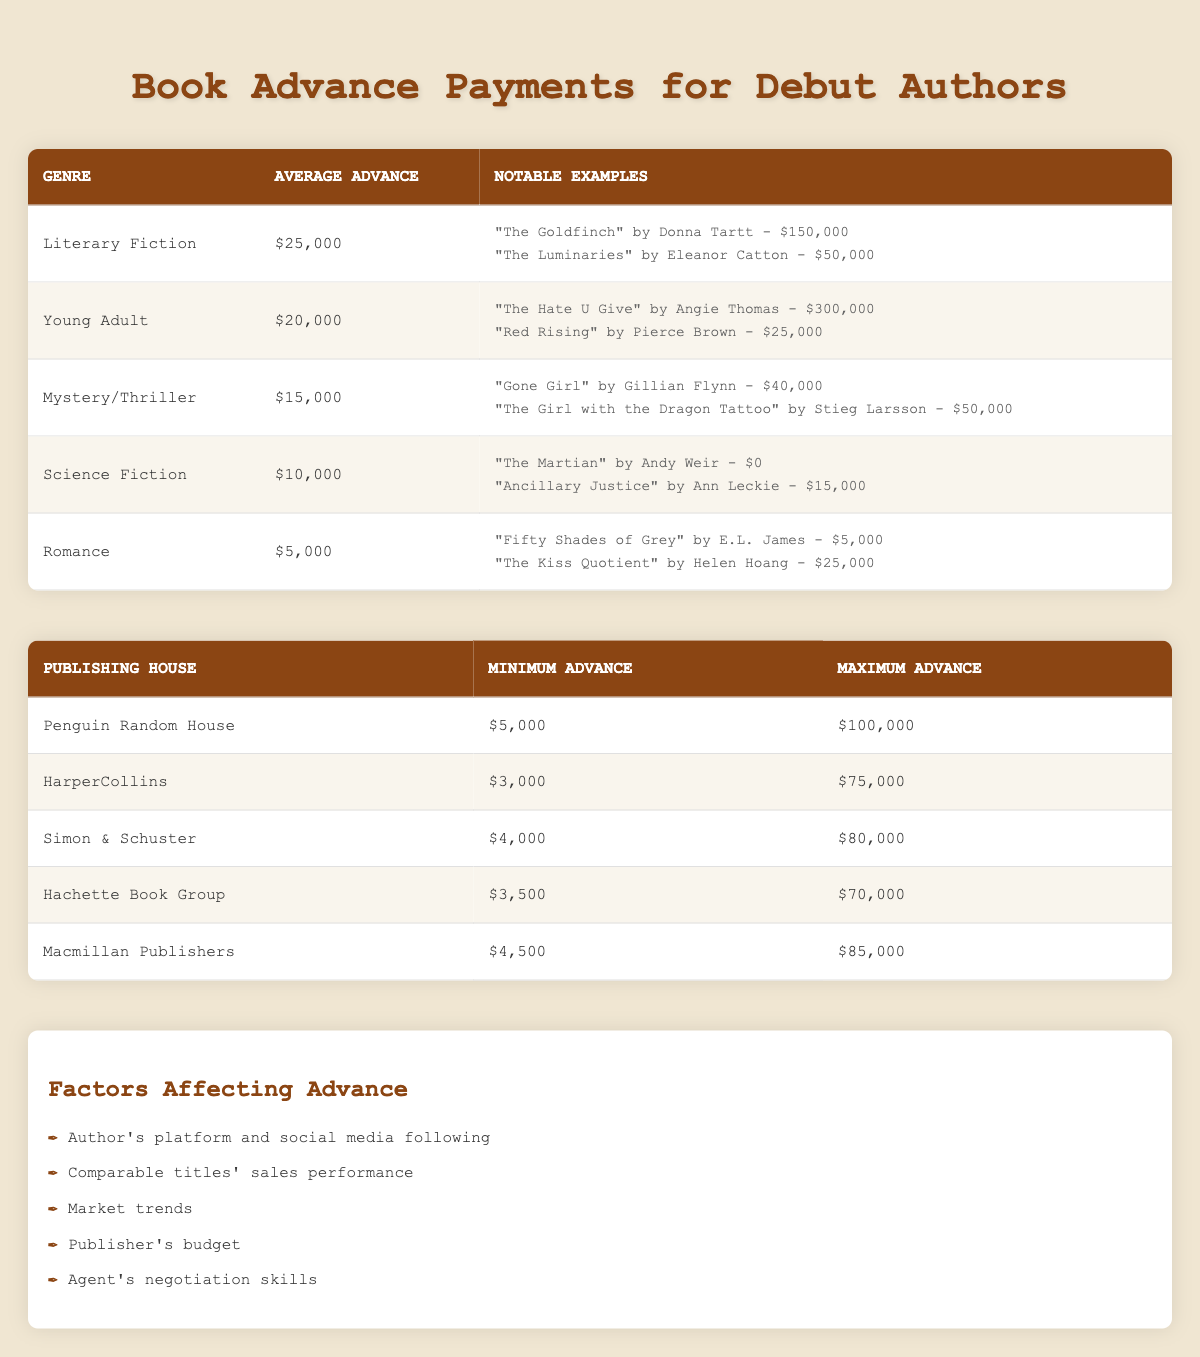What is the average advance for debut authors in the Romance genre? The table shows the average advance for the Romance genre as $5,000 directly under the "Average Advance" column.
Answer: $5,000 Which notable book received the highest advance and what was the amount? Looking at the notable examples in each genre, "The Hate U Give" by Angie Thomas received the highest advance of $300,000.
Answer: $300,000 How much more is the average advance for Young Adult authors compared to Mystery/Thriller authors? The average advance for Young Adult is $20,000 and for Mystery/Thriller it is $15,000. The difference is $20,000 - $15,000 = $5,000.
Answer: $5,000 Do all genres listed have an average advance greater than $5,000? Checking the average advances, Romance has an average advance of $5,000, which is equal to but not greater than $5,000. Therefore, the statement is false.
Answer: No Which publishing house has the highest maximum advance and what is that amount? The maximum advance for Penguin Random House is $100,000, which is the highest among the listed publishing houses.
Answer: $100,000 What is the total range of advances (maximum minus minimum) offered by HarperCollins? HarperCollins has a minimum advance of $3,000 and a maximum advance of $75,000. The range is calculated as $75,000 - $3,000 = $72,000.
Answer: $72,000 Is it true that the average advance for literary fiction is higher than both science fiction and romance combined? The average advance for literary fiction is $25,000, for science fiction is $10,000, and for romance is $5,000. The combined average of science fiction and romance is $10,000 + $5,000 = $15,000, which is less than $25,000. Therefore, the statement is true.
Answer: Yes If an author received the average advance for the Mystery/Thriller genre, what notable examples could that author look up to? The average advance for Mystery/Thriller is $15,000. Notable examples include "Gone Girl" by Gillian Flynn with an advance of $40,000 and "The Girl with the Dragon Tattoo" by Stieg Larsson with an advance of $50,000, both of which are greater than the average.
Answer: "Gone Girl" and "The Girl with the Dragon Tattoo" What average advance is needed for debut authors to make more than the maximum advance offered by Hachette Book Group? Hachette Book Group has a maximum advance of $70,000. To exceed this, the average advance would need to be more than $70,000. The values in the table show no averages exceeding this amount, therefore, an author would need an advance over $70,000.
Answer: More than $70,000 